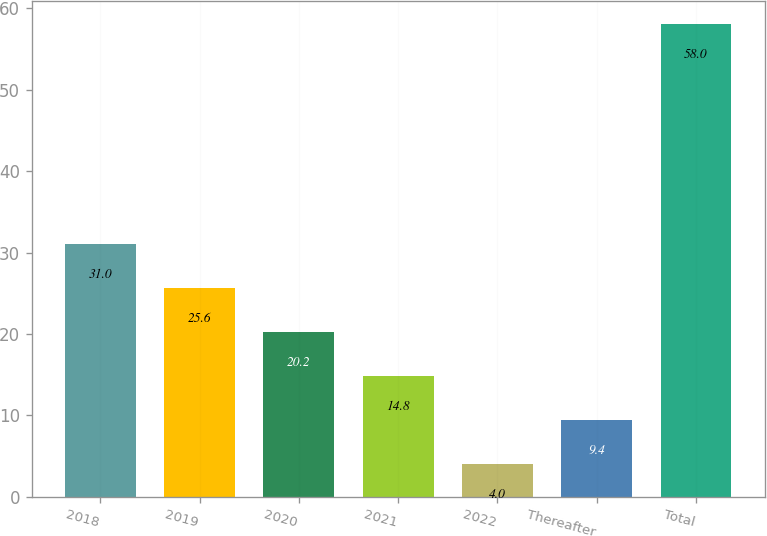<chart> <loc_0><loc_0><loc_500><loc_500><bar_chart><fcel>2018<fcel>2019<fcel>2020<fcel>2021<fcel>2022<fcel>Thereafter<fcel>Total<nl><fcel>31<fcel>25.6<fcel>20.2<fcel>14.8<fcel>4<fcel>9.4<fcel>58<nl></chart> 